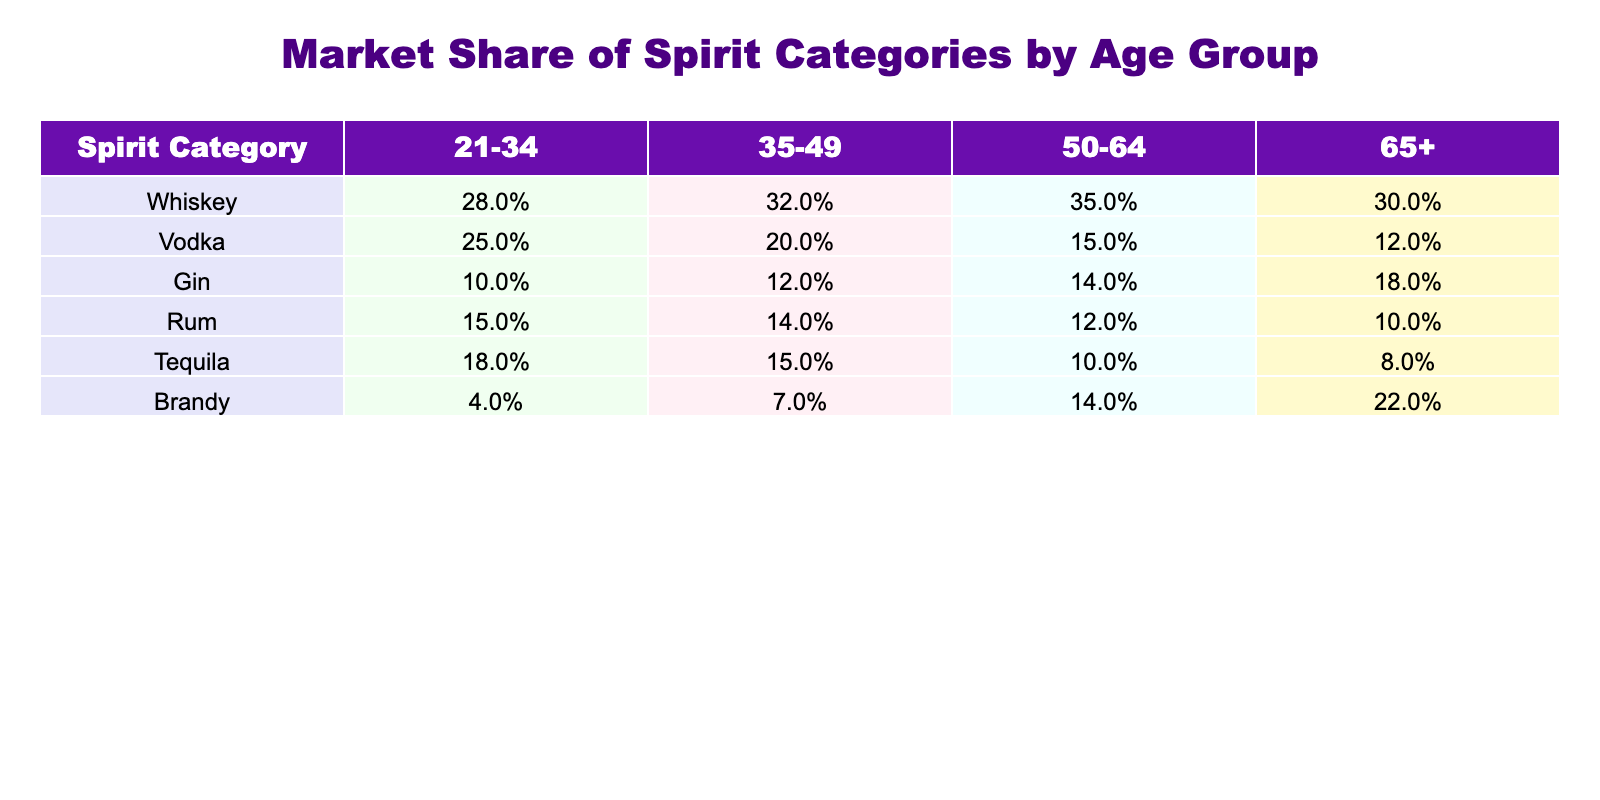What is the market share percentage of Whiskey among the 21-34 age group? According to the table, Whiskey has a market share percentage of 28% in the 21-34 age group.
Answer: 28% Which spirit category has the highest market share among individuals aged 50-64? From the table, Whiskey has the highest share at 35% for the 50-64 age group compared to other categories like Vodka (15%), Gin (14%), Rum (12%), Tequila (10%), and Brandy (14%).
Answer: Whiskey What is the average market share percentage of Gin and Rum across all age groups? The market shares of Gin are 10%, 12%, 14%, and 18% (for ages 21-34, 35-49, 50-64, and 65+) which add up to 54%, and Rum has market shares of 15%, 14%, 12%, and 10%, totaling 51%. Therefore, the average is (54 + 51) / 2 = 52.5%.
Answer: 52.5% Is it true that Tequila has a higher market share than Vodka in the 35-49 age group? In the 35-49 age group, Tequila has a market share of 15% while Vodka has a lower share of 20%. Therefore, it is false that Tequila has a higher market share than Vodka in this age group.
Answer: No What is the total market share percentage of Brandy in the age group of 65+? Looking at the table, Brandy holds a market share of 22% among the 65+ age group.
Answer: 22% Which spirit category has the greatest decline in market share from the 21-34 age group to the 65+ age group? By analyzing the data, Vodka decreases from 25% (21-34) to 12% (65+), resulting in a decline of 13 percentage points. The next largest decline is for Tequila, which goes from 18% to 8%, a decline of 10 percentage points. Thus, Vodka experiences the greatest decline.
Answer: Vodka Which age group has an equal market share percentage for Gin and Rum? Both Gin and Rum have a market share of 14% in the 50-64 age group. There is no other age group where both categories share the same percentage.
Answer: 50-64 What is the total market share percentage of Whiskey and Gin in the 35-49 age group? For the 35-49 age group, Whiskey has a market share of 32% and Gin has 12%. Adding these together gives us a total of 32 + 12 = 44%.
Answer: 44% 